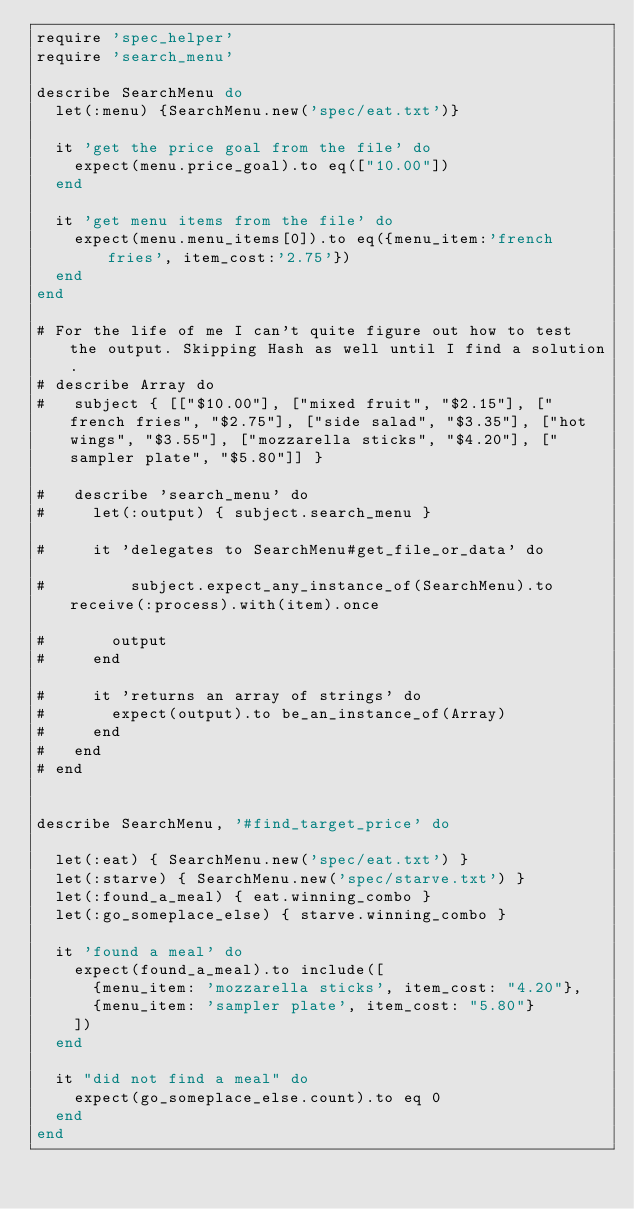<code> <loc_0><loc_0><loc_500><loc_500><_Ruby_>require 'spec_helper'
require 'search_menu'

describe SearchMenu do
  let(:menu) {SearchMenu.new('spec/eat.txt')}

  it 'get the price goal from the file' do
    expect(menu.price_goal).to eq(["10.00"])
  end

  it 'get menu items from the file' do
    expect(menu.menu_items[0]).to eq({menu_item:'french fries', item_cost:'2.75'})
  end
end

# For the life of me I can't quite figure out how to test the output. Skipping Hash as well until I find a solution.
# describe Array do
#   subject { [["$10.00"], ["mixed fruit", "$2.15"], ["french fries", "$2.75"], ["side salad", "$3.35"], ["hot wings", "$3.55"], ["mozzarella sticks", "$4.20"], ["sampler plate", "$5.80"]] }

#   describe 'search_menu' do
#     let(:output) { subject.search_menu }

#     it 'delegates to SearchMenu#get_file_or_data' do

#         subject.expect_any_instance_of(SearchMenu).to receive(:process).with(item).once

#       output
#     end

#     it 'returns an array of strings' do
#       expect(output).to be_an_instance_of(Array)
#     end
#   end
# end


describe SearchMenu, '#find_target_price' do

  let(:eat) { SearchMenu.new('spec/eat.txt') }
  let(:starve) { SearchMenu.new('spec/starve.txt') }
  let(:found_a_meal) { eat.winning_combo }
  let(:go_someplace_else) { starve.winning_combo }

  it 'found a meal' do
    expect(found_a_meal).to include([
      {menu_item: 'mozzarella sticks', item_cost: "4.20"},
      {menu_item: 'sampler plate', item_cost: "5.80"}
    ])
  end

  it "did not find a meal" do
    expect(go_someplace_else.count).to eq 0
  end
end



</code> 